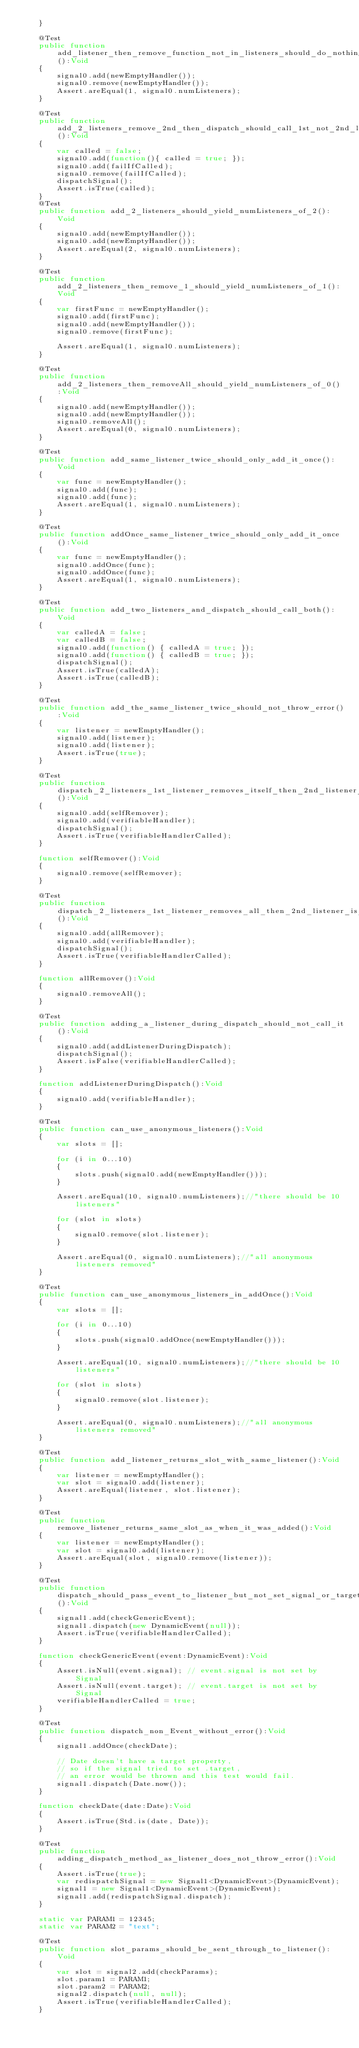<code> <loc_0><loc_0><loc_500><loc_500><_Haxe_>	}

	@Test
	public function add_listener_then_remove_function_not_in_listeners_should_do_nothing():Void
	{
		signal0.add(newEmptyHandler());
		signal0.remove(newEmptyHandler());
		Assert.areEqual(1, signal0.numListeners);
	}

	@Test
	public function add_2_listeners_remove_2nd_then_dispatch_should_call_1st_not_2nd_listener():Void
	{
		var called = false;
		signal0.add(function(){ called = true; });
		signal0.add(failIfCalled);
		signal0.remove(failIfCalled);
		dispatchSignal();
		Assert.isTrue(called);
	}
	@Test
	public function add_2_listeners_should_yield_numListeners_of_2():Void
	{
		signal0.add(newEmptyHandler());
		signal0.add(newEmptyHandler());
		Assert.areEqual(2, signal0.numListeners);
	}

	@Test
	public function add_2_listeners_then_remove_1_should_yield_numListeners_of_1():Void
	{
		var firstFunc = newEmptyHandler();
		signal0.add(firstFunc);
		signal0.add(newEmptyHandler());
		signal0.remove(firstFunc);
		
		Assert.areEqual(1, signal0.numListeners);
	}

	@Test
	public function add_2_listeners_then_removeAll_should_yield_numListeners_of_0():Void
	{
		signal0.add(newEmptyHandler());
		signal0.add(newEmptyHandler());
		signal0.removeAll();
		Assert.areEqual(0, signal0.numListeners);
	}
	
	@Test
	public function add_same_listener_twice_should_only_add_it_once():Void
	{
		var func = newEmptyHandler();
		signal0.add(func);
		signal0.add(func);
		Assert.areEqual(1, signal0.numListeners);
	}

	@Test
	public function addOnce_same_listener_twice_should_only_add_it_once():Void
	{
		var func = newEmptyHandler();
		signal0.addOnce(func);
		signal0.addOnce(func);
		Assert.areEqual(1, signal0.numListeners);
	}

	@Test
	public function add_two_listeners_and_dispatch_should_call_both():Void
	{
		var calledA = false;
		var calledB = false;
		signal0.add(function() { calledA = true; });
		signal0.add(function() { calledB = true; });
		dispatchSignal();
		Assert.isTrue(calledA);
		Assert.isTrue(calledB);
	}

	@Test
	public function add_the_same_listener_twice_should_not_throw_error():Void
	{
		var listener = newEmptyHandler();
		signal0.add(listener);
		signal0.add(listener);
		Assert.isTrue(true);
	}

	@Test
	public function dispatch_2_listeners_1st_listener_removes_itself_then_2nd_listener_is_still_called():Void
	{
		signal0.add(selfRemover);
		signal0.add(verifiableHandler);
		dispatchSignal();
		Assert.isTrue(verifiableHandlerCalled);
	}

	function selfRemover():Void
	{
		signal0.remove(selfRemover);
	}

	@Test
	public function dispatch_2_listeners_1st_listener_removes_all_then_2nd_listener_is_still_called():Void
	{
		signal0.add(allRemover);
		signal0.add(verifiableHandler);
		dispatchSignal();
		Assert.isTrue(verifiableHandlerCalled);
	}

	function allRemover():Void
	{
		signal0.removeAll();
	}

	@Test
	public function adding_a_listener_during_dispatch_should_not_call_it():Void
	{
		signal0.add(addListenerDuringDispatch);
		dispatchSignal();
		Assert.isFalse(verifiableHandlerCalled);
	}
	
	function addListenerDuringDispatch():Void
	{
		signal0.add(verifiableHandler);
	}

	@Test
	public function can_use_anonymous_listeners():Void
	{
		var slots = [];
		
		for (i in 0...10)
		{
			slots.push(signal0.add(newEmptyHandler()));
		}

		Assert.areEqual(10, signal0.numListeners);//"there should be 10 listeners"

		for (slot in slots)
		{
			signal0.remove(slot.listener);
		}

		Assert.areEqual(0, signal0.numListeners);//"all anonymous listeners removed"
	}
	
	@Test
	public function can_use_anonymous_listeners_in_addOnce():Void
	{
		var slots = [];
		
		for (i in 0...10)
		{
			slots.push(signal0.addOnce(newEmptyHandler()));
		}

		Assert.areEqual(10, signal0.numListeners);//"there should be 10 listeners"

		for (slot in slots)
		{
			signal0.remove(slot.listener);
		}

		Assert.areEqual(0, signal0.numListeners);//"all anonymous listeners removed"
	}

	@Test
	public function add_listener_returns_slot_with_same_listener():Void
	{
		var listener = newEmptyHandler();
		var slot = signal0.add(listener);
		Assert.areEqual(listener, slot.listener);
	}
	
	@Test
	public function remove_listener_returns_same_slot_as_when_it_was_added():Void
	{
		var listener = newEmptyHandler();
		var slot = signal0.add(listener);
		Assert.areEqual(slot, signal0.remove(listener));
	}

	@Test
	public function dispatch_should_pass_event_to_listener_but_not_set_signal_or_target_properties():Void
	{
		signal1.add(checkGenericEvent);
		signal1.dispatch(new DynamicEvent(null));
		Assert.isTrue(verifiableHandlerCalled);
	}
	
	function checkGenericEvent(event:DynamicEvent):Void
	{
		Assert.isNull(event.signal); // event.signal is not set by Signal
		Assert.isNull(event.target); // event.target is not set by Signal
		verifiableHandlerCalled = true;
	}
	
	@Test
	public function dispatch_non_Event_without_error():Void
	{
		signal1.addOnce(checkDate);

		// Date doesn't have a target property,
		// so if the signal tried to set .target,
		// an error would be thrown and this test would fail.
		signal1.dispatch(Date.now());
	}
	
	function checkDate(date:Date):Void
	{
		Assert.isTrue(Std.is(date, Date));
	}
	
	@Test
	public function adding_dispatch_method_as_listener_does_not_throw_error():Void
	{
		Assert.isTrue(true);
		var redispatchSignal = new Signal1<DynamicEvent>(DynamicEvent);
		signal1 = new Signal1<DynamicEvent>(DynamicEvent);
		signal1.add(redispatchSignal.dispatch);
	}

	static var PARAM1 = 12345;
	static var PARAM2 = "text";

	@Test
	public function slot_params_should_be_sent_through_to_listener():Void
	{
		var slot = signal2.add(checkParams);
		slot.param1 = PARAM1;
		slot.param2 = PARAM2;
		signal2.dispatch(null, null);
		Assert.isTrue(verifiableHandlerCalled);
	}
</code> 